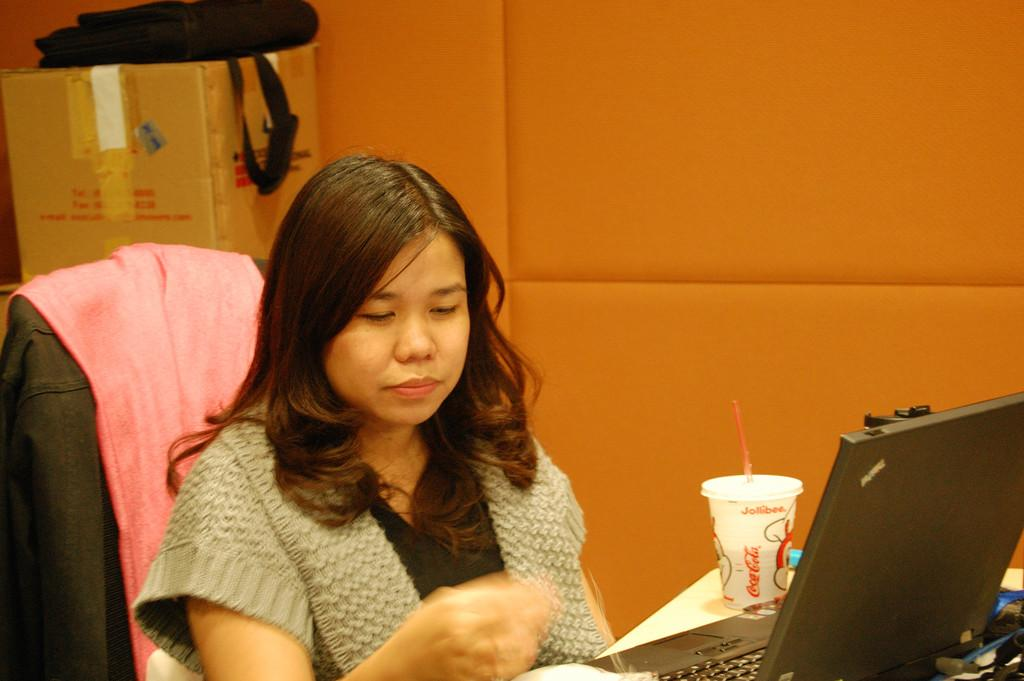What is the woman doing in the image? The woman is sitting on a chair in the image. What object is on the table in the image? There is a laptop and a cup on a table in the image. What can be seen in the background of the image? There is a cardboard box, a bag, and a wall in the background of the image. What type of heart is visible in the image? There is no heart visible in the image. 